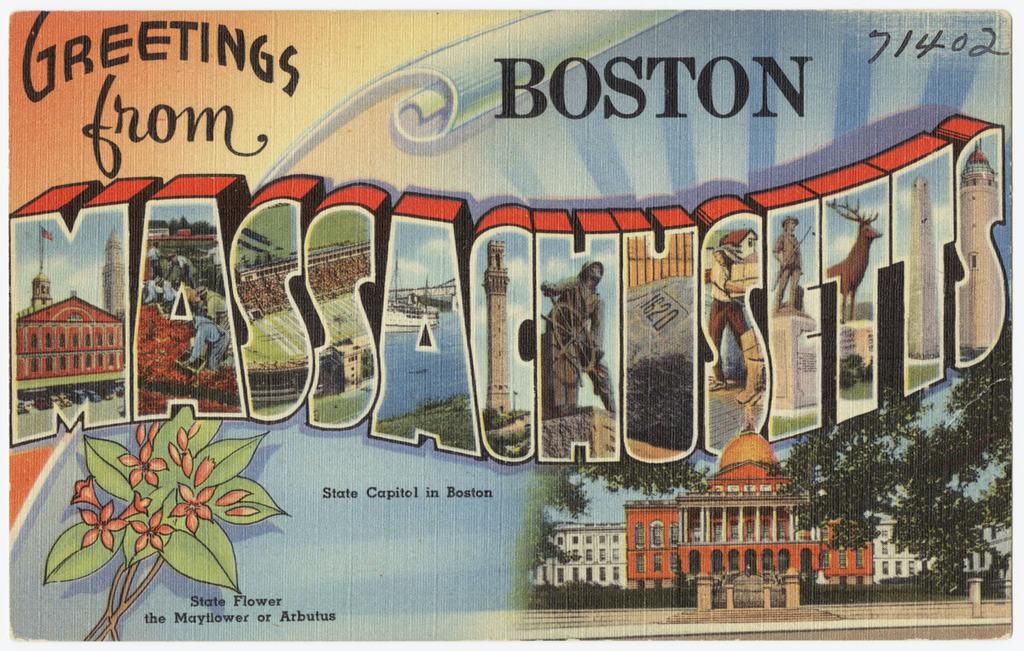Which city is being feature?
Provide a succinct answer. Boston. What is the state flower of massachusetts?
Make the answer very short. Mayflower. 